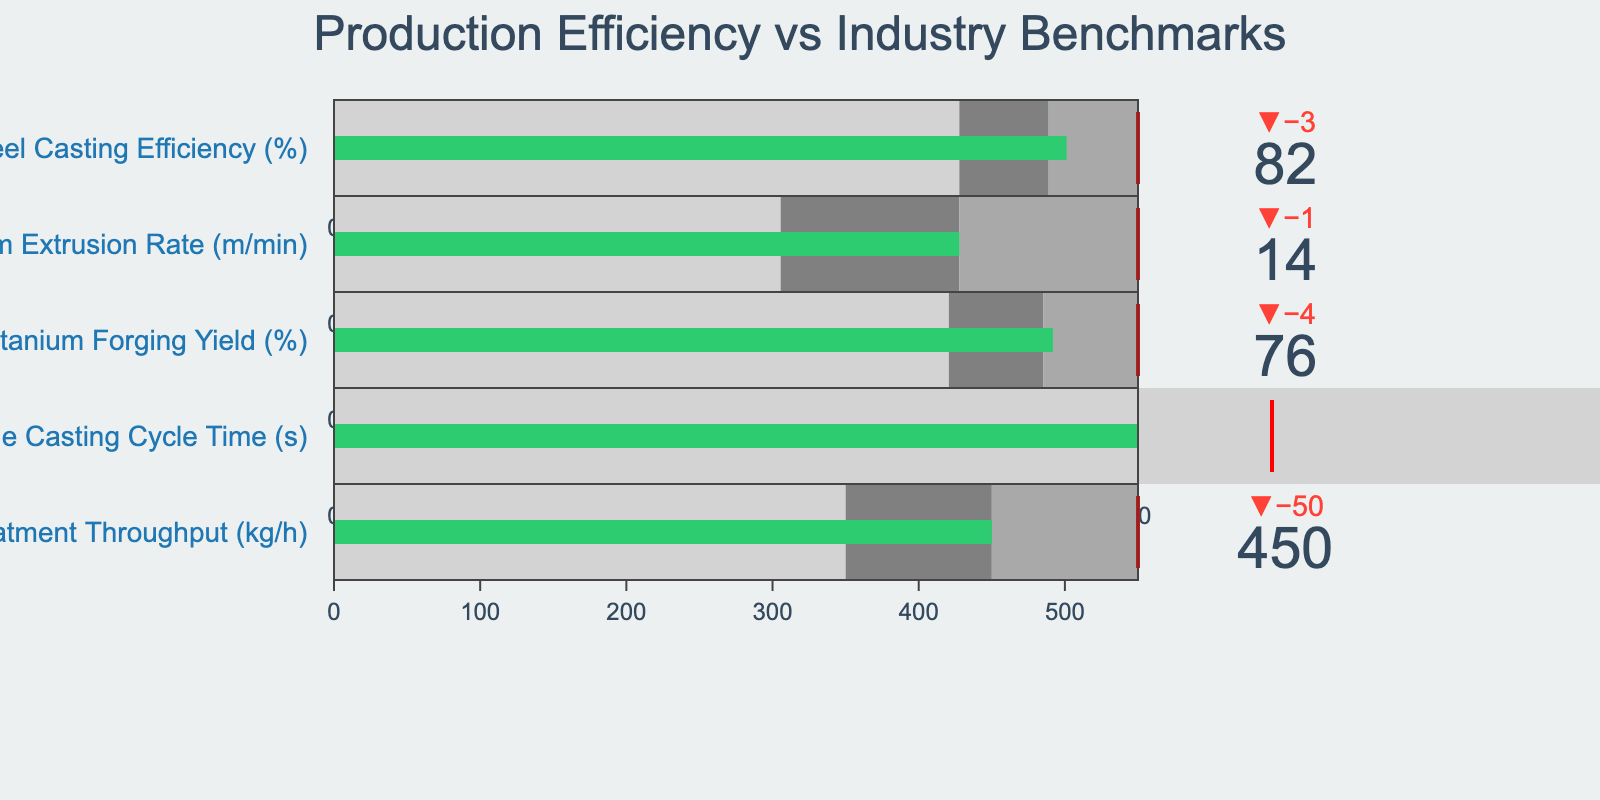What is the title of the figure? The title of the figure is located at the top and is typically the largest text element.
Answer: Production Efficiency vs Industry Benchmarks What is the actual efficiency percentage for Steel Casting? Locate the value next to Steel Casting Efficiency (%), within the bullet indicator.
Answer: 82% What is the comparative rate for Aluminum Extrusion? The comparative rate is the reference value shown as a small line on the gauge.
Answer: 15 m/min Which manufacturing process has the lowest actual value? Compare the actual values for all processes and identify the lowest one.
Answer: Magnesium Die Casting Cycle Time (45 s) Is Titanium Forging Yield above its target value? Compare the actual value (76%) with the target value (85%).
Answer: No What is the difference between the actual and target values for Nickel Alloy Heat Treatment Throughput? Subtract the actual value (450 kg/h) from the target value (550 kg/h). Calculation: 550 - 450.
Answer: 100 kg/h How does the actual Magnesium Die Casting Cycle Time compare to the comparative value? The actual (45 s) is compared to the comparative (40 s) directly.
Answer: Higher Which process has the highest target value and what is it? Examine all target values and identify the highest one.
Answer: Nickel Alloy Heat Treatment Throughput (550 kg/h) In which range does the Steel Casting Efficiency fall? Identify the ranges and observe where the actual value (82%) is located. Ranges: [0-70, 70-80, 80-90].
Answer: Third range (80-90%) Are any processes outperforming their targets? Compare each actual value to its corresponding target value across all processes.
Answer: No 